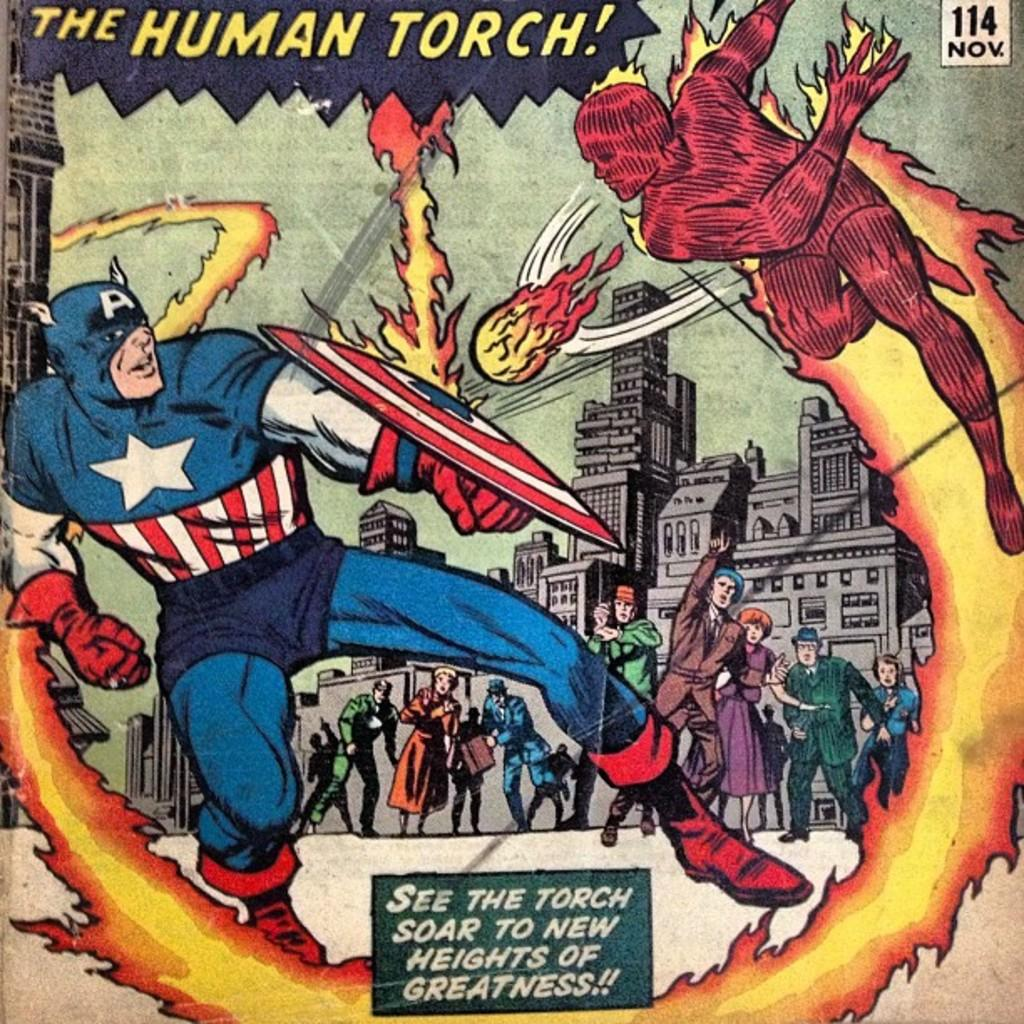<image>
Provide a brief description of the given image. A cover of a copy of "The Human Torch!" comic book shows the Torch throwing fire balls at Captain America. 